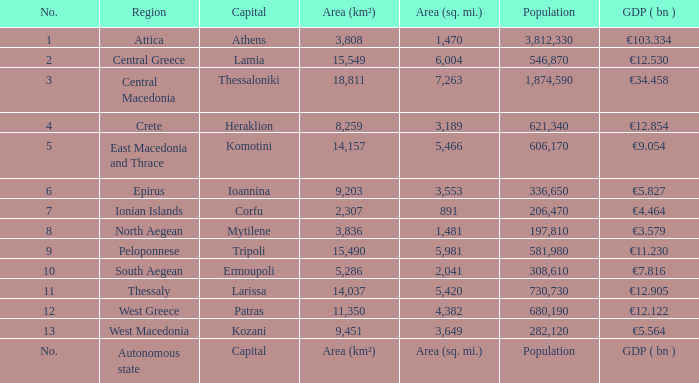In an area with a square mileage, what is the population? Population. 